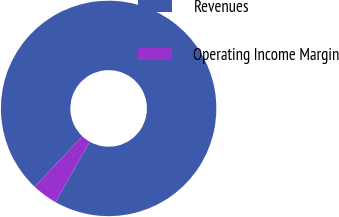Convert chart. <chart><loc_0><loc_0><loc_500><loc_500><pie_chart><fcel>Revenues<fcel>Operating Income Margin<nl><fcel>96.15%<fcel>3.85%<nl></chart> 